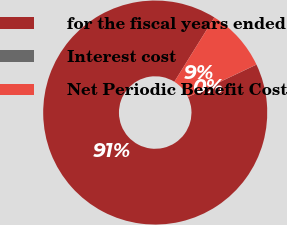<chart> <loc_0><loc_0><loc_500><loc_500><pie_chart><fcel>for the fiscal years ended<fcel>Interest cost<fcel>Net Periodic Benefit Cost<nl><fcel>90.89%<fcel>0.01%<fcel>9.1%<nl></chart> 